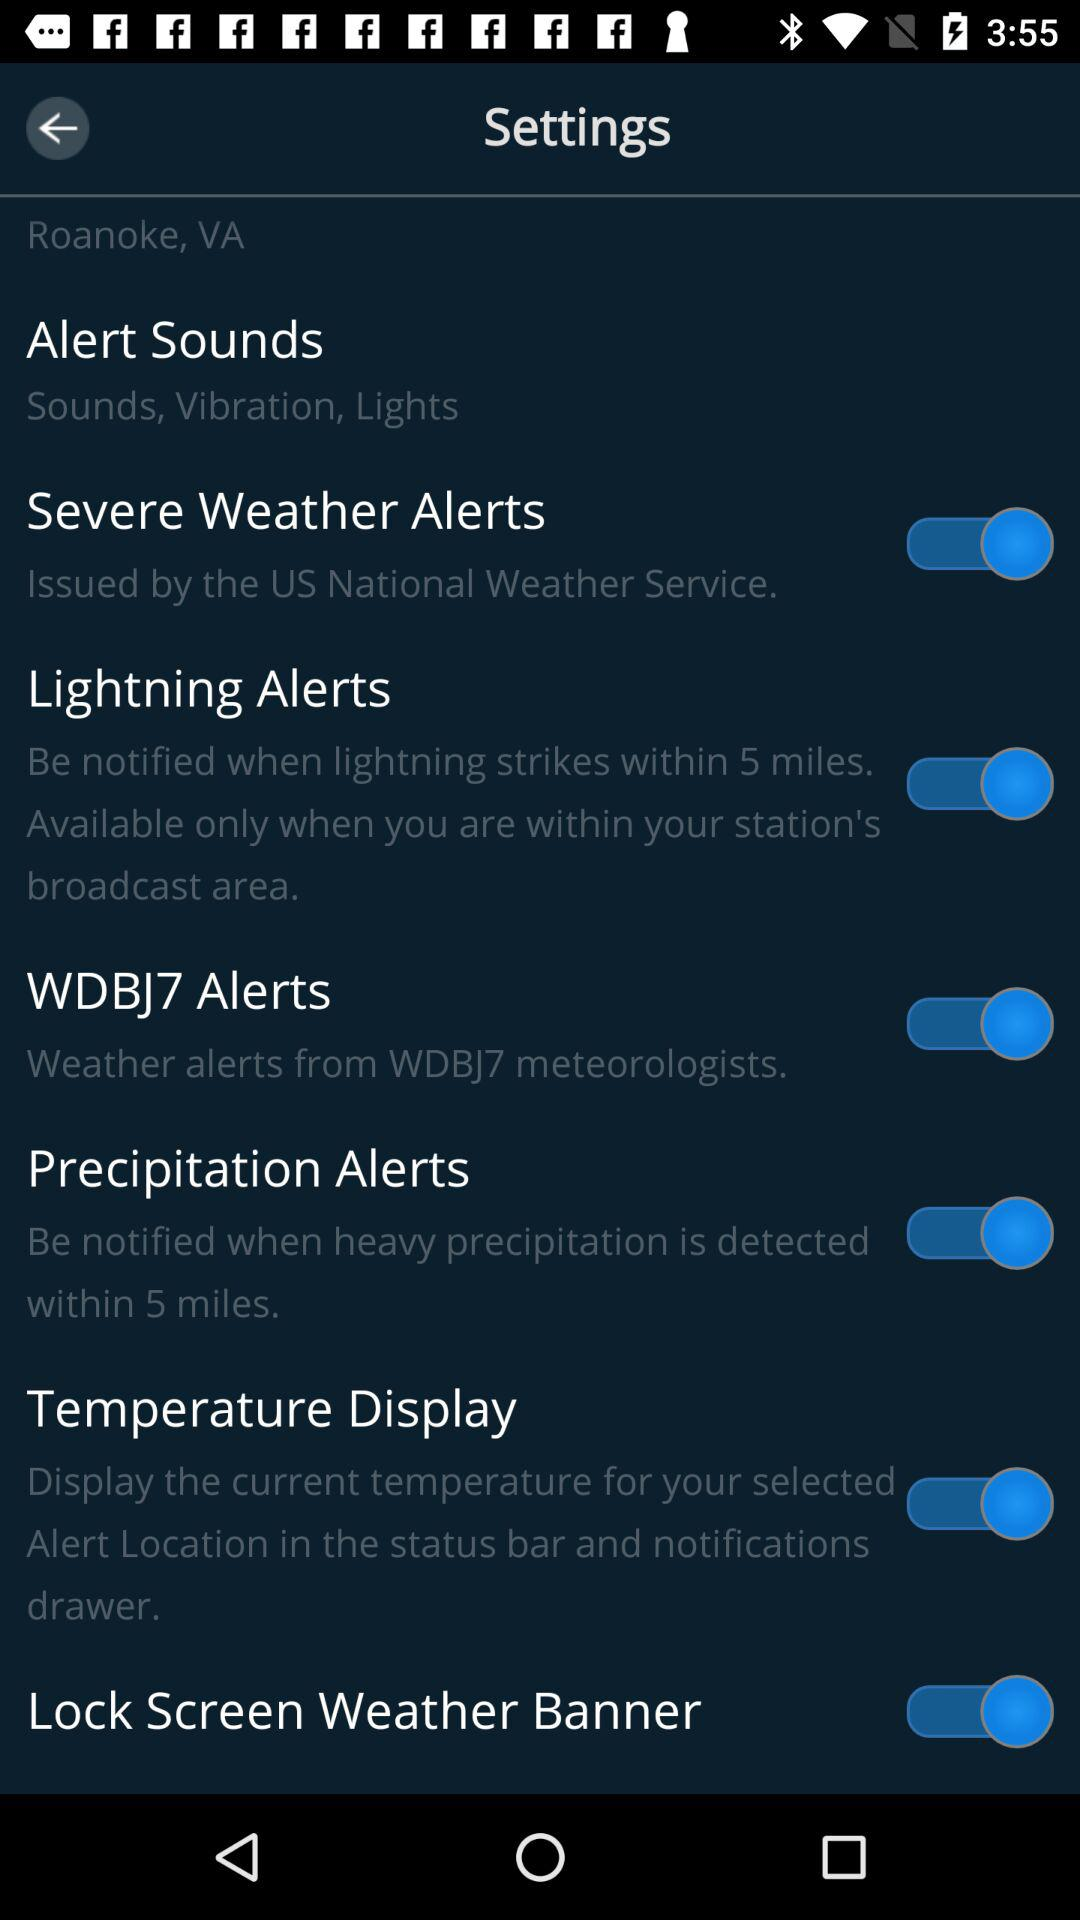How many of the alerts are issued by the US National Weather Service?
Answer the question using a single word or phrase. 1 